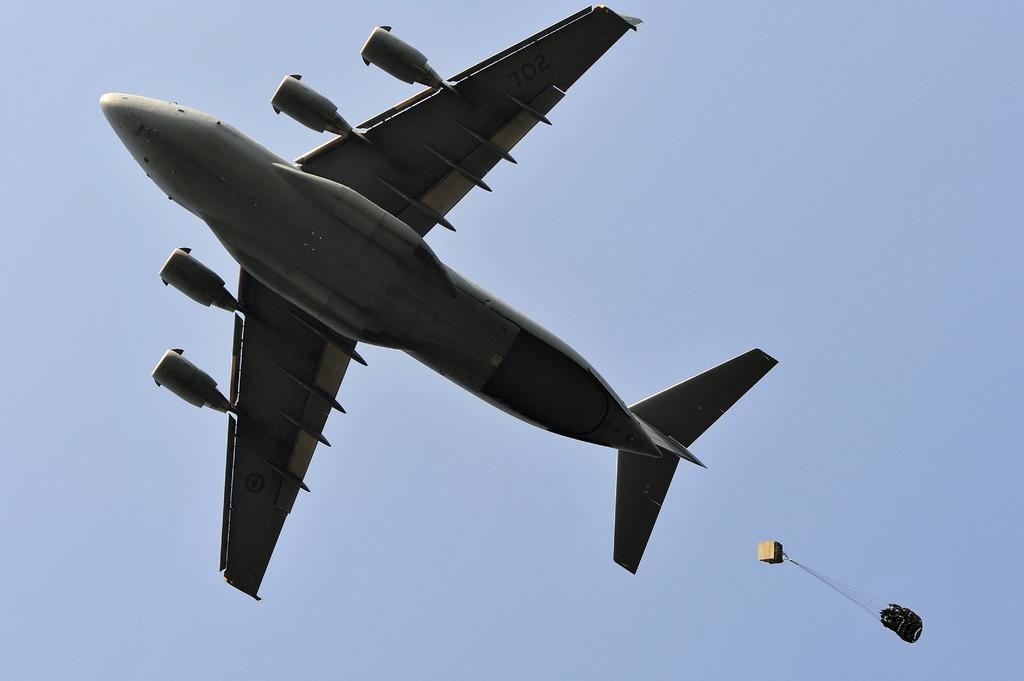Describe this image in one or two sentences. In this image I can see an aeroplane flying in the air. In the bottom right-hand corner there is a parachute. In the background, I can see the sky in blue color. 